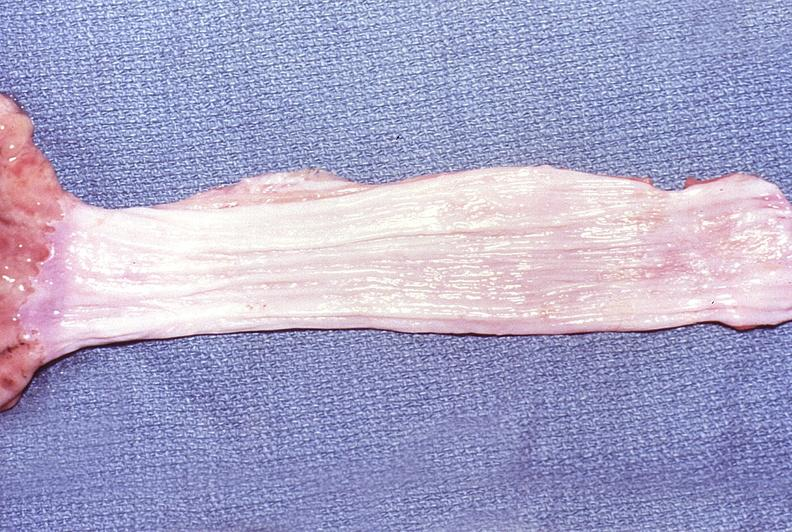s gastrointestinal present?
Answer the question using a single word or phrase. Yes 